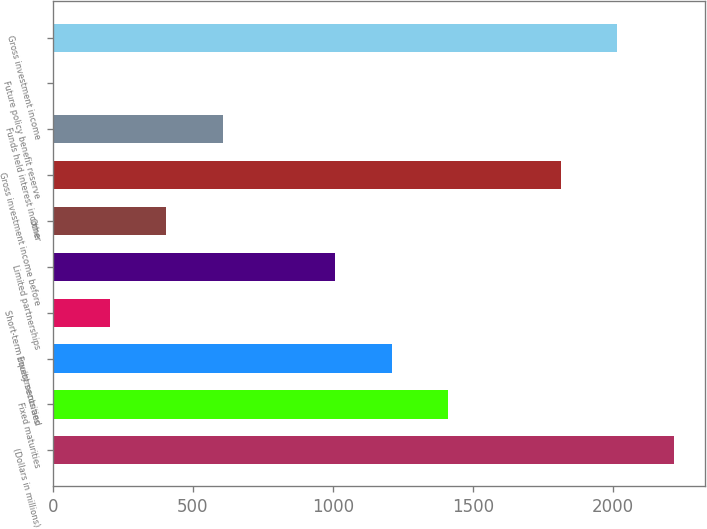<chart> <loc_0><loc_0><loc_500><loc_500><bar_chart><fcel>(Dollars in millions)<fcel>Fixed maturities<fcel>Equity securities<fcel>Short-term investments and<fcel>Limited partnerships<fcel>Other<fcel>Gross investment income before<fcel>Funds held interest income<fcel>Future policy benefit reserve<fcel>Gross investment income<nl><fcel>2217.44<fcel>1411.68<fcel>1210.24<fcel>203.04<fcel>1008.8<fcel>404.48<fcel>1814.56<fcel>605.92<fcel>1.6<fcel>2016<nl></chart> 